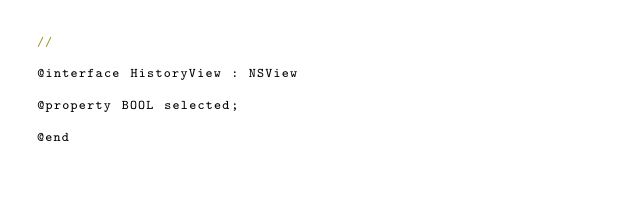Convert code to text. <code><loc_0><loc_0><loc_500><loc_500><_C_>//

@interface HistoryView : NSView

@property BOOL selected;

@end
</code> 